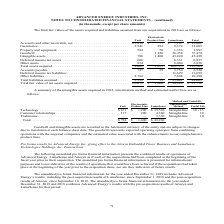According to Advanced Energy's financial document, What was the fair value of Inventories from Trek? According to the financial document, 3,941 (in thousands). The relevant text states: "Inventories . 3,941 292 9,372 13,605 Property and equipment . 594 50 1,353 1,997 Goodwill . — 1,220 36,258 37,478 Intan..." Also, What was the fair value of  Property and equipment from LumaSense? According to the financial document, 1,353 (in thousands). The relevant text states: "292 9,372 13,605 Property and equipment . 594 50 1,353 1,997 Goodwill . — 1,220 36,258 37,478 Intangible assets . 788 1,400 43,240 45,428 Deferred income..." Also, What was the fair value of Goodwill from Electrostatic Product Line? According to the financial document, 1,220 (in thousands). The relevant text states: "y and equipment . 594 50 1,353 1,997 Goodwill . — 1,220 36,258 37,478 Intangible assets . 788 1,400 43,240 45,428 Deferred income tax assets . 606 — 6,331..." Also, can you calculate: What was the difference between the fair value of Inventories between Trek and LumaSense? Based on the calculation: 9,372-3,941, the result is 5431 (in thousands). This is based on the information: "Inventories . 3,941 292 9,372 13,605 Property and equipment . 594 50 1,353 1,997 Goodwill . — 1,220 36,258 37,478 Intan Inventories . 3,941 292 9,372 13,605 Property and equipment . 594 50 1,353 1,997..." The key data points involved are: 3,941, 9,372. Also, can you calculate: What was the difference between the total fair value of Inventories and Goodwill? Based on the calculation: 37,478-13,605, the result is 23873 (in thousands). This is based on the information: "nt . 594 50 1,353 1,997 Goodwill . — 1,220 36,258 37,478 Intangible assets . 788 1,400 43,240 45,428 Deferred income tax assets . 606 — 6,331 6,937 Other as Inventories . 3,941 292 9,372 13,605 Proper..." The key data points involved are: 13,605, 37,478. Also, can you calculate: What is the sum of the 3 highest total assets types? Based on the calculation: 13,605+37,478+45,428, the result is 96511 (in thousands). This is based on the information: "6,258 37,478 Intangible assets . 788 1,400 43,240 45,428 Deferred income tax assets . 606 — 6,331 6,937 Other assets . 854 — 6,004 6,858 Total assets acquir nt . 594 50 1,353 1,997 Goodwill . — 1,220 ..." The key data points involved are: 13,605, 37,478, 45,428. 